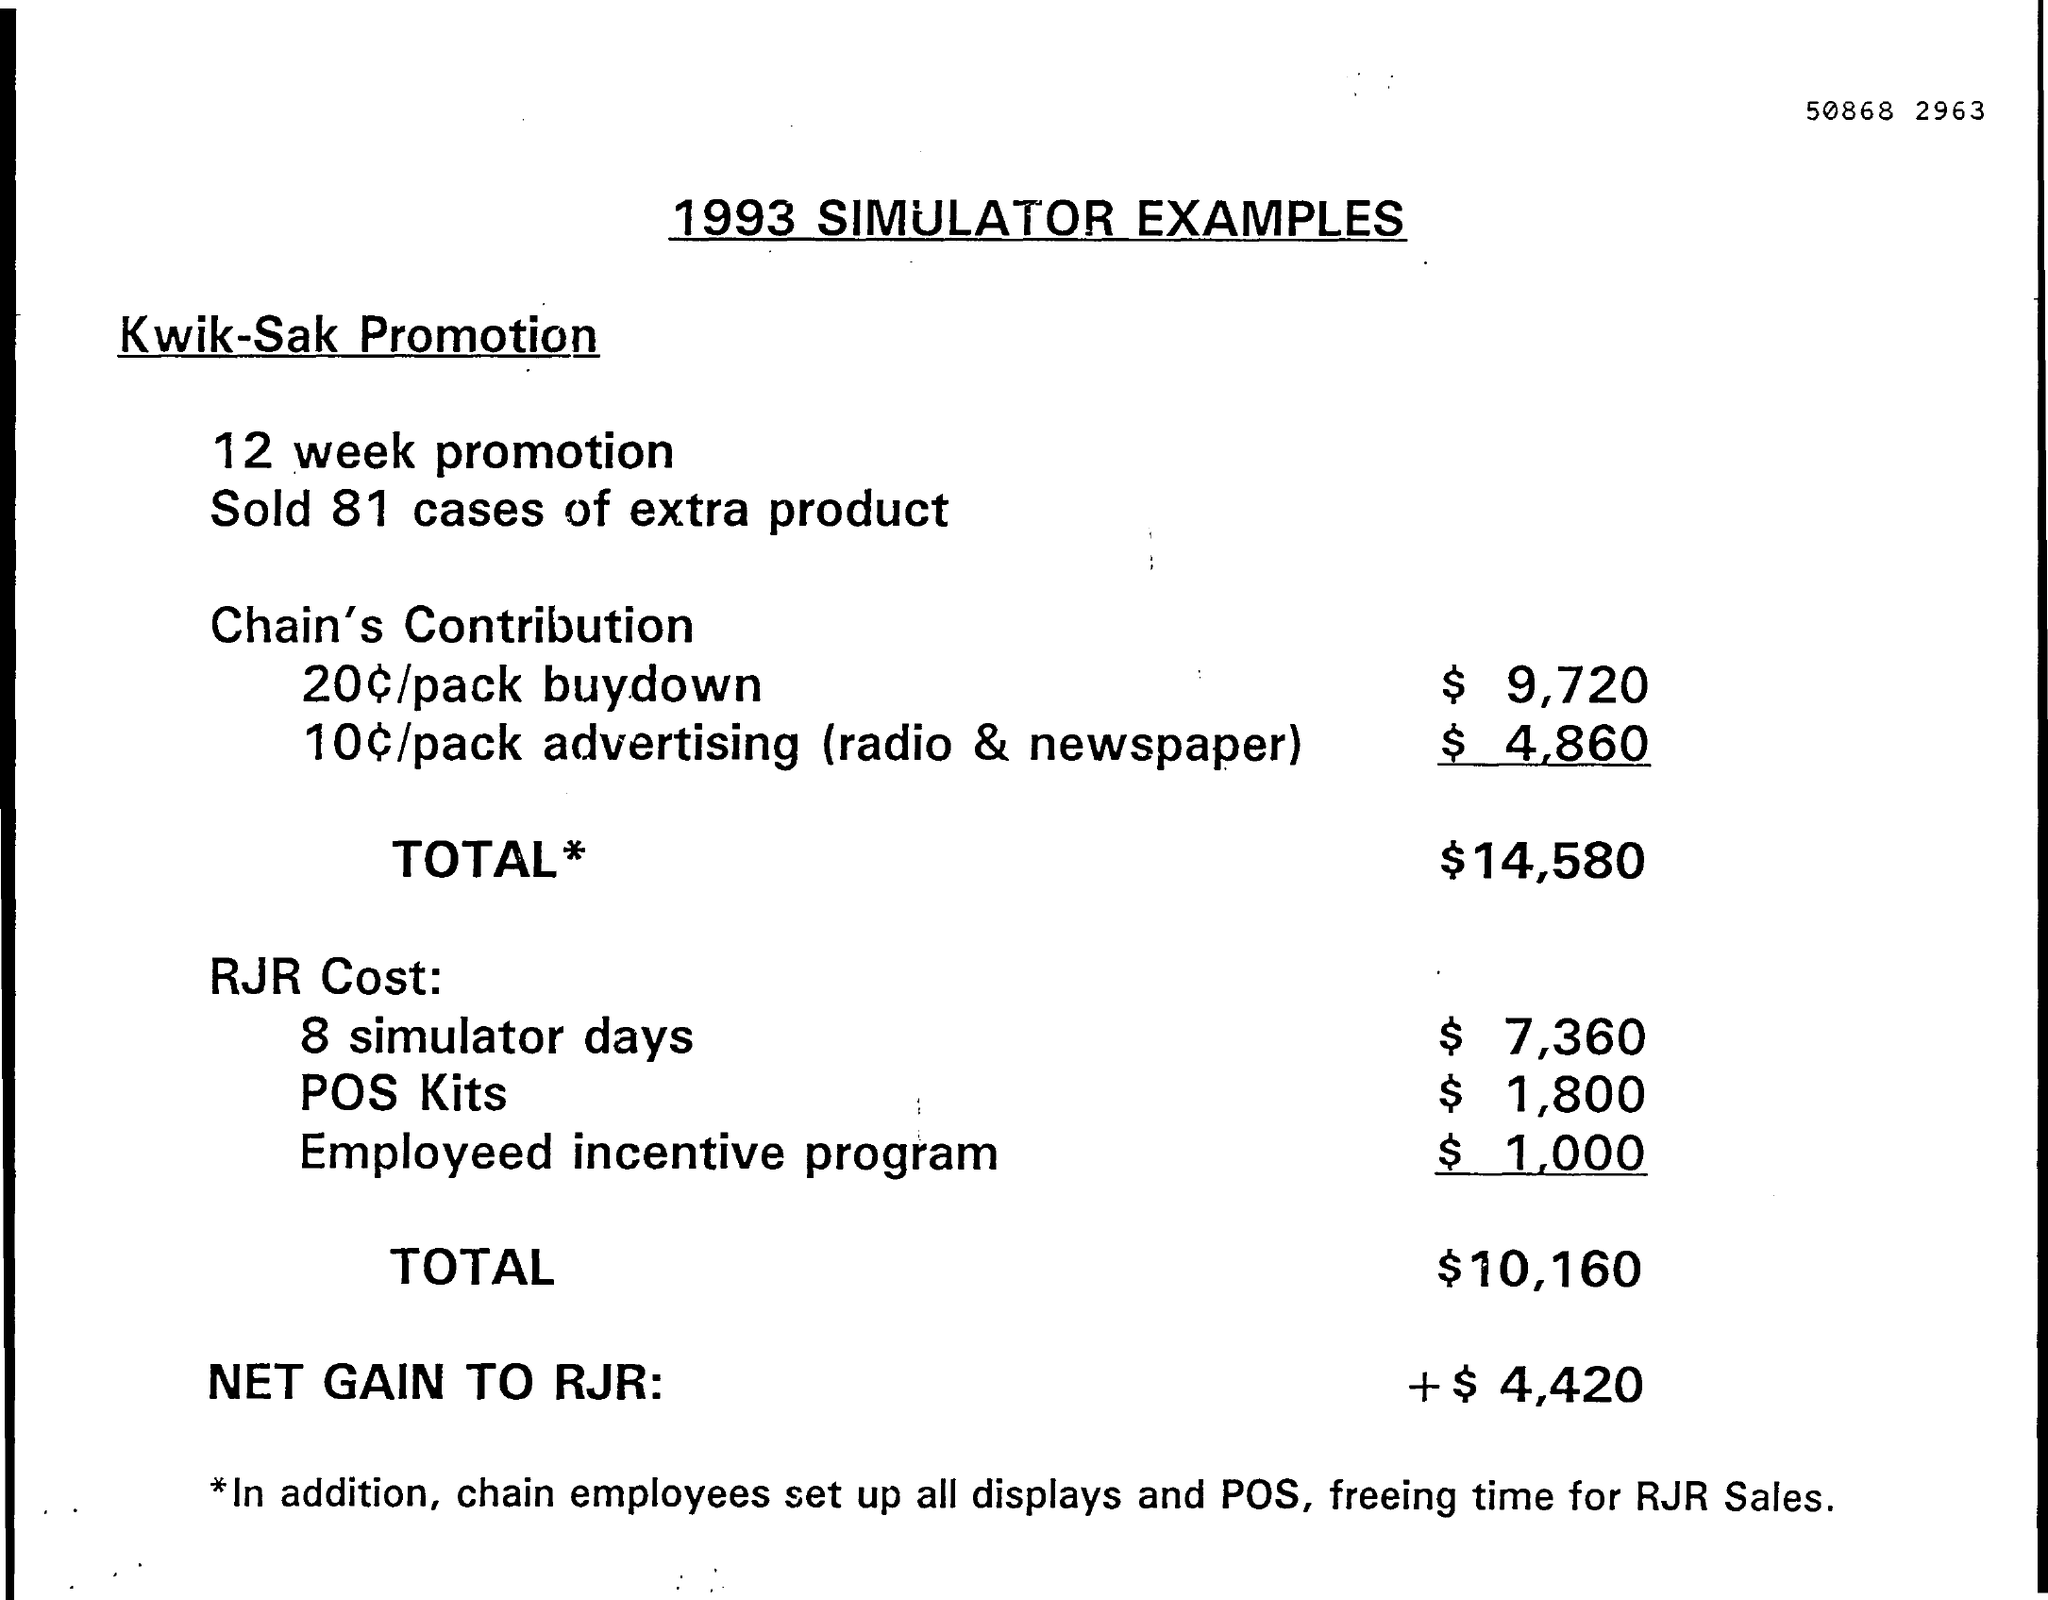List a handful of essential elements in this visual. A total of 81 extra product cases were sold. The year to which these simulator examples belong is 1993. The net gain of RJR is estimated to be approximately $4,420. China's total contribution is $14,580. The total cost of RJR is $10,160. 